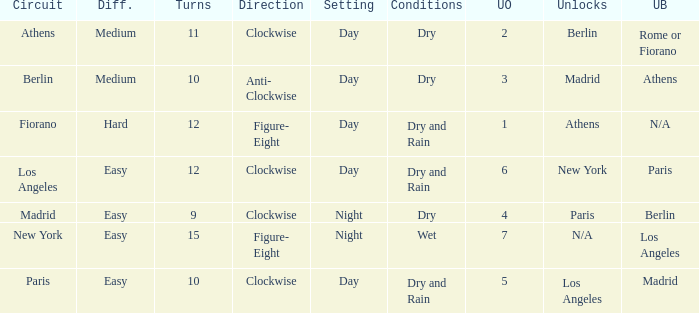What are the conditions for the athens circuit? Dry. 